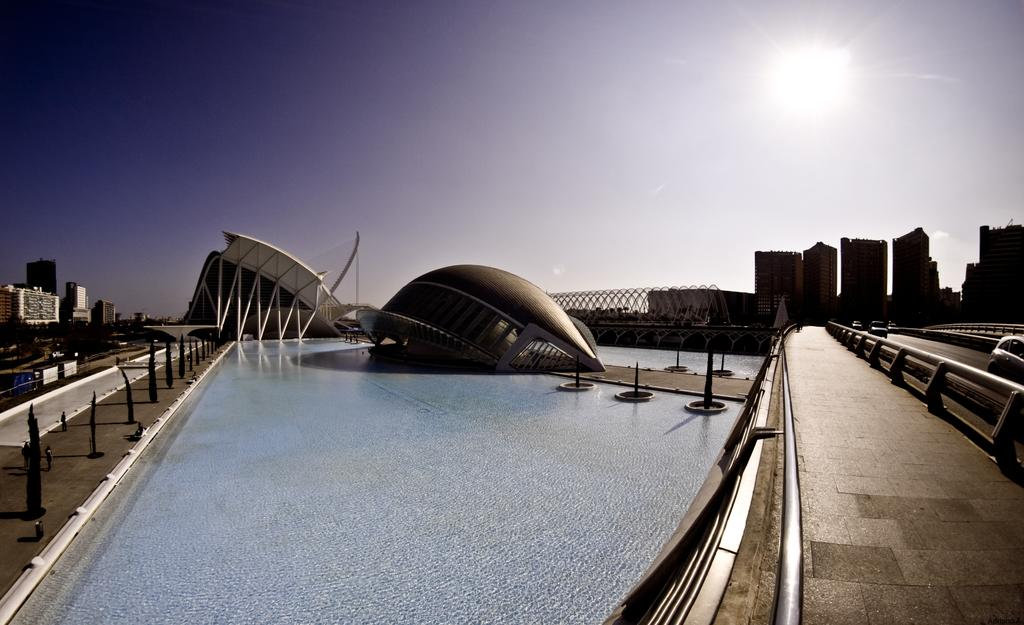What is the primary element visible in the image? There is water in the image. What can be seen in the distance behind the water? There are buildings in the background of the image. Are there any vehicles present in the image? Yes, there are vehicles on the road in the right corner of the image. What type of book is being read by the ray in the image? There is no ray or book present in the image. 